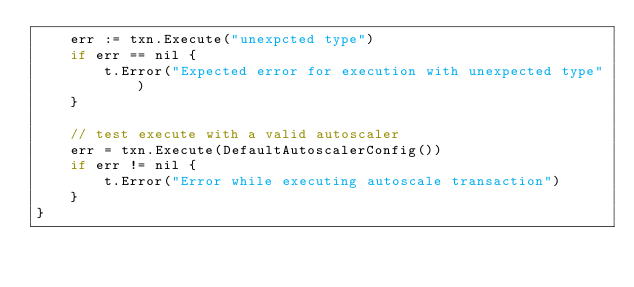<code> <loc_0><loc_0><loc_500><loc_500><_Go_>	err := txn.Execute("unexpcted type")
	if err == nil {
		t.Error("Expected error for execution with unexpected type")
	}

	// test execute with a valid autoscaler
	err = txn.Execute(DefaultAutoscalerConfig())
	if err != nil {
		t.Error("Error while executing autoscale transaction")
	}
}</code> 